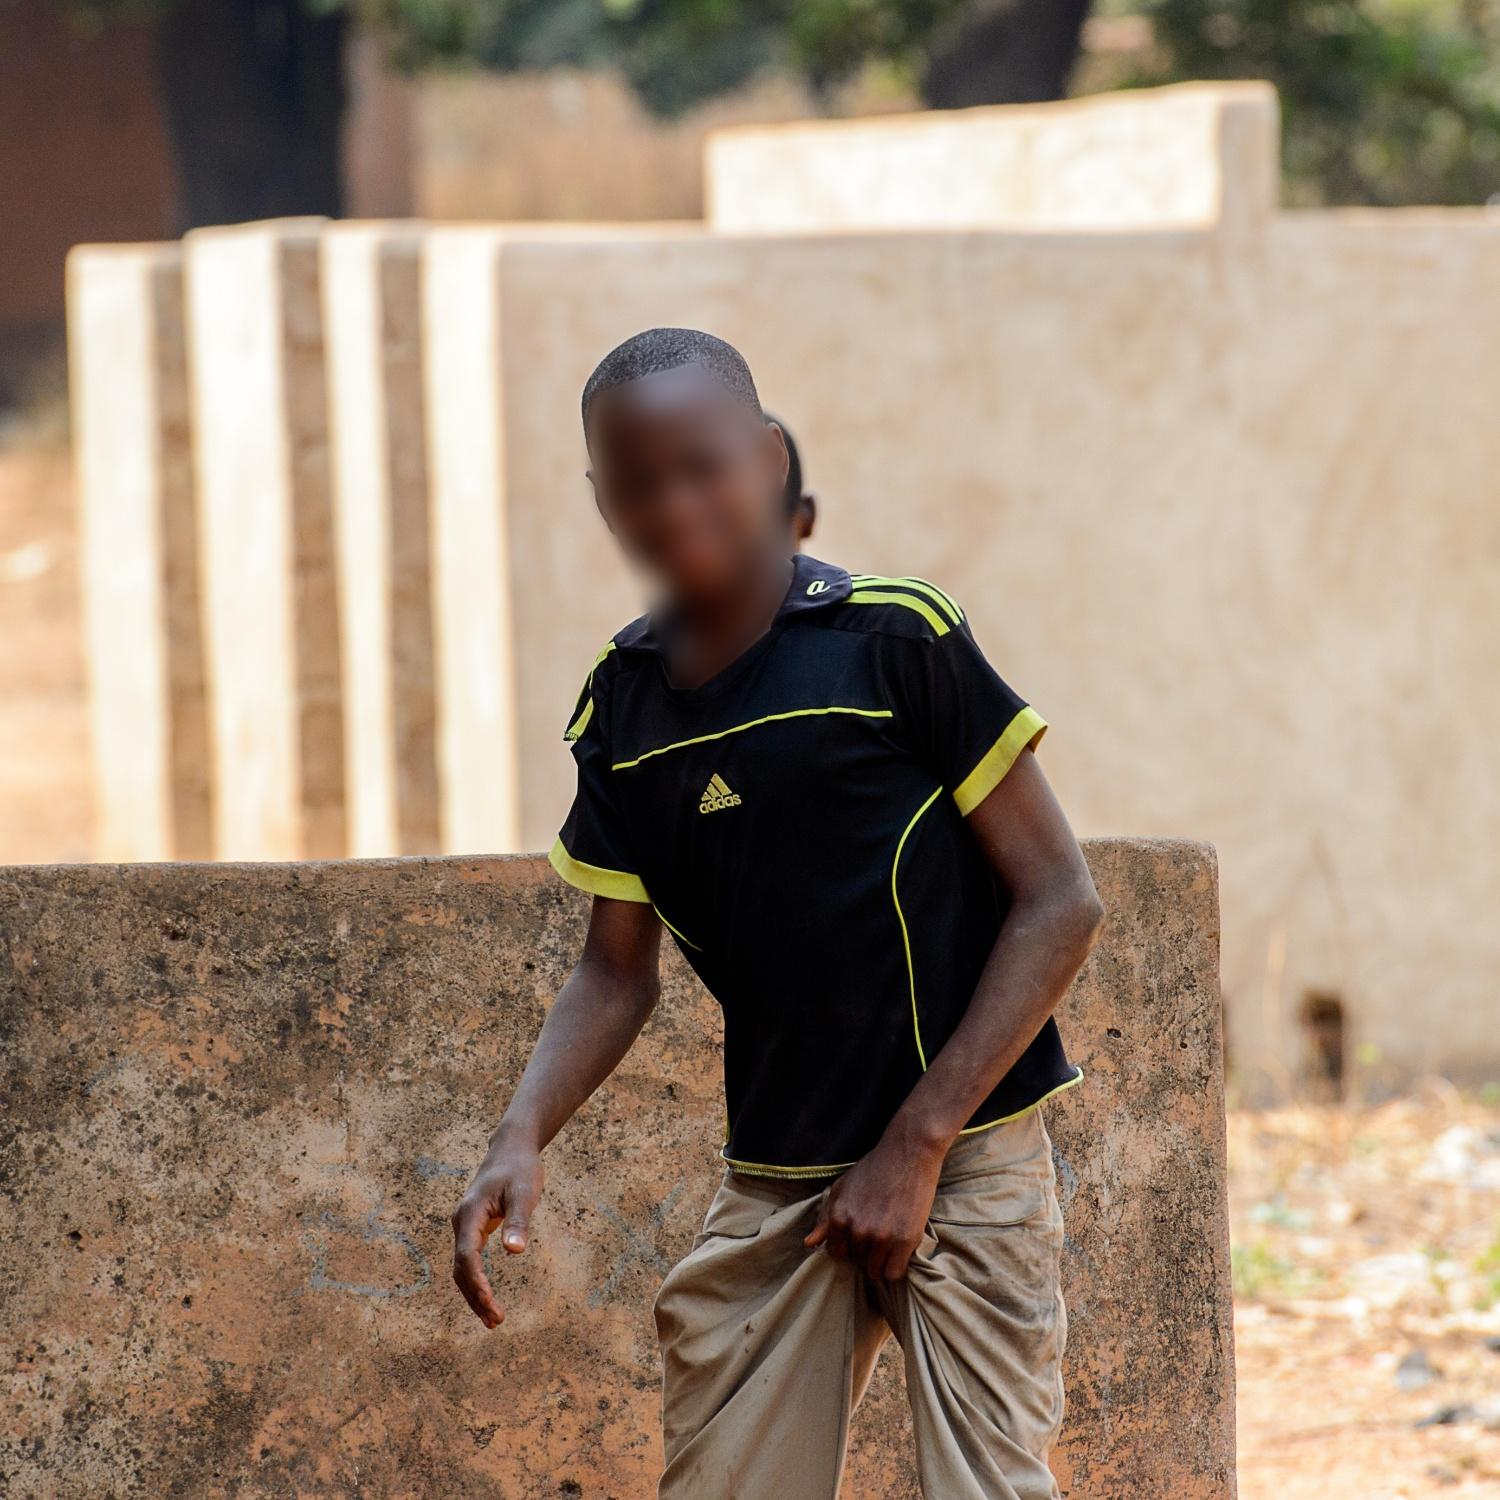Can you elaborate on the surroundings seen in the image? The surroundings in the image reveal an environment that blends both natural and man-made elements. The most prominent man-made feature is a series of concrete walls, arranged in a staggered manner, giving depth to the background. These walls have a weathered, rustic appearance, indicative of prolonged exposure to the elements. In contrast to these structures are the natural features: the ground is bare earth, suggesting an outdoor rural setting. Trees are visible in the distance, their foliage breaking the monotony of the otherwise arid land. This combination of natural and constructed elements creates a visually interesting environment that conveys a sense of simplicity and ruggedness. What kind of activities could someone do in this area? Given the outdoor setting and open space, this area appears well-suited for a range of activities. Children could use the space for playing games such as soccer, tag, or hide and seek, taking advantage of the walls for creative play scenarios. The less densely vegetated space and dirt ground suggest it’s also a place where local community members might gather for social activities or even small community events. Additionally, it could serve as a spot for informal sports or exercise given the space available. The mixture of structures may also provide shaded areas for resting or socializing during warmer parts of the day. Imagine the boy in the image is a character in a story. What kind of story could this be? In a story, the boy in the image could be the protagonist of an adventure unfolding in a rural village. He might be a curious and energetic child who explores the nooks and crannies of his village, uncovering hidden paths and secret spots behind the walls. His black and yellow Adidas shirt could be a gift from a relative far away, symbolizing a connection to a larger world beyond the village. The story could follow his day-to-day life, mingling mundane tasks with moments of discovery and excitement. Perhaps he stumbles upon an old map revealing a forgotten treasure hidden in the forest. The concrete walls become obstacles to climb and navigate, the trees his allies, and the vast open reddish land his playground awaiting each day’s new adventure. 